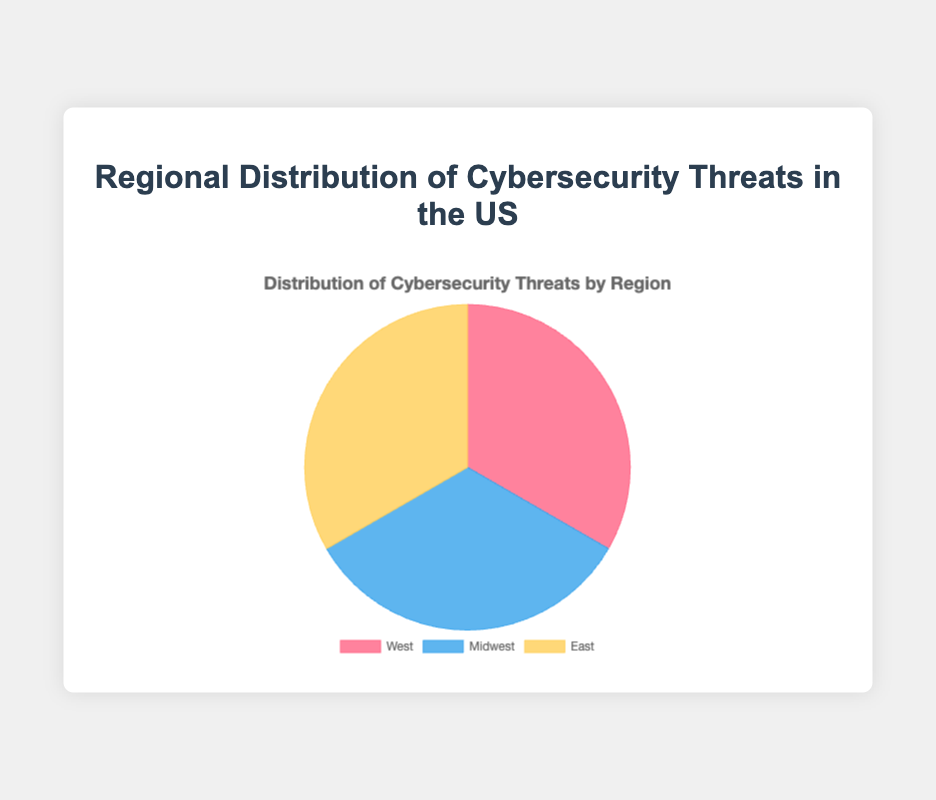Which region has the highest percentage of cybersecurity threats? To determine the highest percentage of cybersecurity threats, look at the pie chart segments and compare their sizes or the associated percentages.
Answer: West Which region has the smallest percentage of cybersecurity threats? To find the region with the smallest percentage of threats, look at the pie chart segments and identify the smallest one.
Answer: East What is the sum of the percentages of cybersecurity threats in the Midwest and East regions? Add the percentages of the Midwest and East regions from the pie chart: Midwest (100) + East (100) = 200%
Answer: 200% Is the percentage of threats in the West region greater than the Midwest? Compare the sizes/percentages of the West and Midwest regions in the pie chart.
Answer: Yes Which regions have equal percentages of cybersecurity threats? Compare the percentages of each region in the pie chart.
Answer: Midwest and East What color represents the West region in the pie chart? Identify the color of the segment labeled as "West" in the pie chart.
Answer: Red What is the combined percentage of the cybersecurity threats for regions other than the West? Add the percentages of Midwest and East regions from the pie chart: Midwest (100) + East (100) = 200%
Answer: 200% Are the DDoS attacks' threat levels distributed equally across all regions? Review the threat levels for "DDoSAttacks" in each region's data. Midwest and East are equal with 25, while West has 20.
Answer: No In which region do ransomware threats make up 30% of the cybersecurity threats? Look at the threat levels for "Ransomware" across the regions to identify where it amounts to 30%. Both West and East have this level.
Answer: West and East 